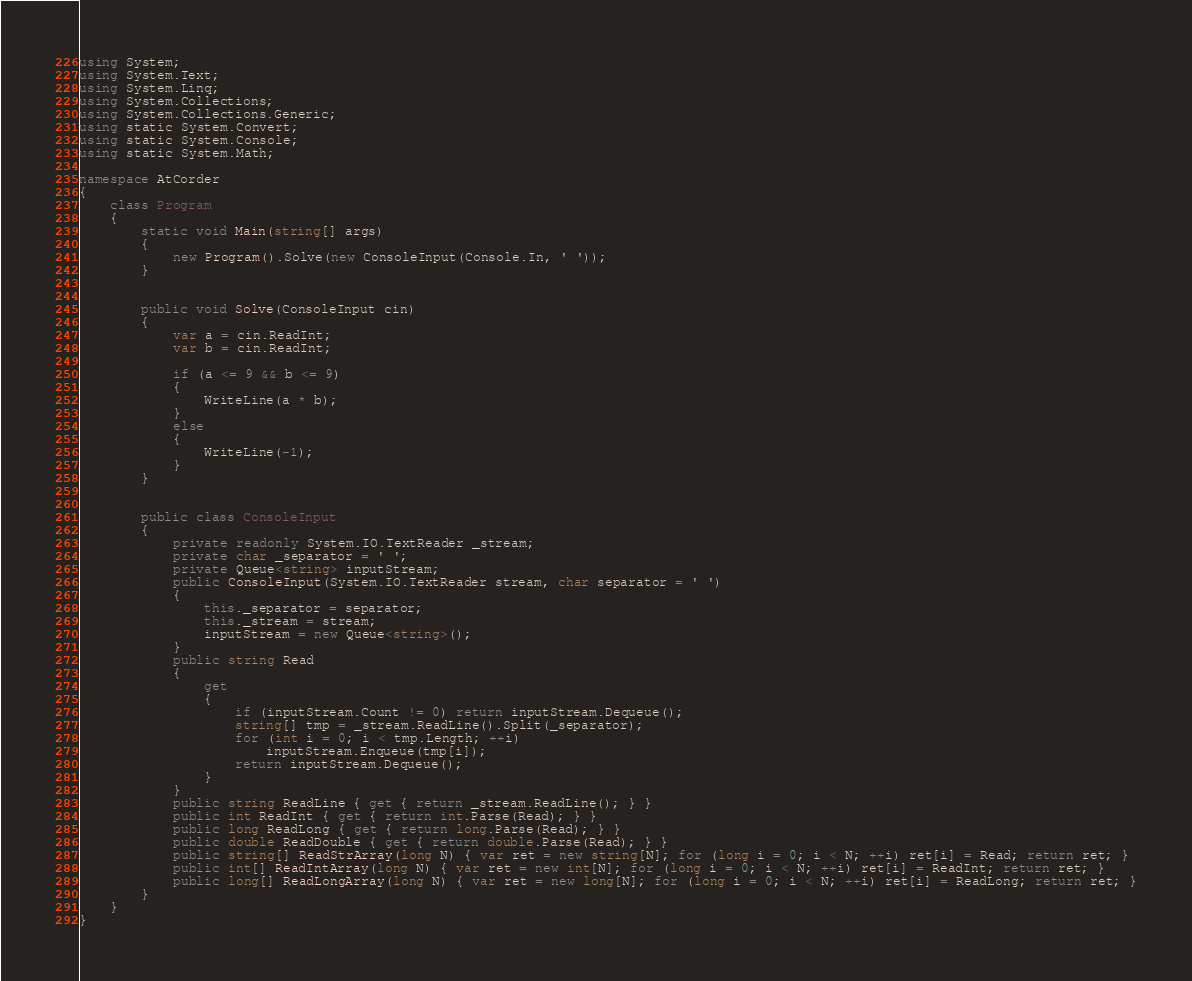<code> <loc_0><loc_0><loc_500><loc_500><_C#_>using System;
using System.Text;
using System.Linq;
using System.Collections;
using System.Collections.Generic;
using static System.Convert;
using static System.Console;
using static System.Math;

namespace AtCorder
{
    class Program
    {
        static void Main(string[] args)
        {
            new Program().Solve(new ConsoleInput(Console.In, ' '));
        }


        public void Solve(ConsoleInput cin)
        {
            var a = cin.ReadInt;
            var b = cin.ReadInt;

            if (a <= 9 && b <= 9)
            {
                WriteLine(a * b);
            }
            else
            {
                WriteLine(-1);
            }
        }


        public class ConsoleInput
        {
            private readonly System.IO.TextReader _stream;
            private char _separator = ' ';
            private Queue<string> inputStream;
            public ConsoleInput(System.IO.TextReader stream, char separator = ' ')
            {
                this._separator = separator;
                this._stream = stream;
                inputStream = new Queue<string>();
            }
            public string Read
            {
                get
                {
                    if (inputStream.Count != 0) return inputStream.Dequeue();
                    string[] tmp = _stream.ReadLine().Split(_separator);
                    for (int i = 0; i < tmp.Length; ++i)
                        inputStream.Enqueue(tmp[i]);
                    return inputStream.Dequeue();
                }
            }
            public string ReadLine { get { return _stream.ReadLine(); } }
            public int ReadInt { get { return int.Parse(Read); } }
            public long ReadLong { get { return long.Parse(Read); } }
            public double ReadDouble { get { return double.Parse(Read); } }
            public string[] ReadStrArray(long N) { var ret = new string[N]; for (long i = 0; i < N; ++i) ret[i] = Read; return ret; }
            public int[] ReadIntArray(long N) { var ret = new int[N]; for (long i = 0; i < N; ++i) ret[i] = ReadInt; return ret; }
            public long[] ReadLongArray(long N) { var ret = new long[N]; for (long i = 0; i < N; ++i) ret[i] = ReadLong; return ret; }
        }
    }
}
</code> 